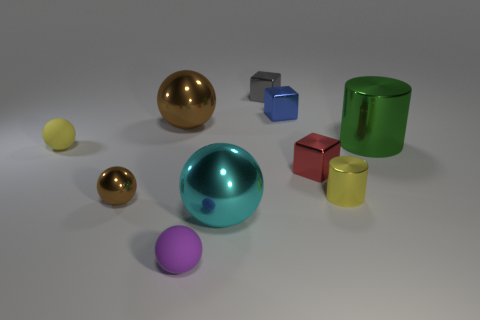Subtract all cyan metal spheres. How many spheres are left? 4 Subtract all blue cylinders. How many brown spheres are left? 2 Subtract all purple balls. How many balls are left? 4 Subtract 1 spheres. How many spheres are left? 4 Subtract all blocks. How many objects are left? 7 Subtract all cyan spheres. Subtract all blue cylinders. How many spheres are left? 4 Subtract 1 gray blocks. How many objects are left? 9 Subtract all big brown objects. Subtract all red metallic blocks. How many objects are left? 8 Add 2 cyan spheres. How many cyan spheres are left? 3 Add 7 yellow things. How many yellow things exist? 9 